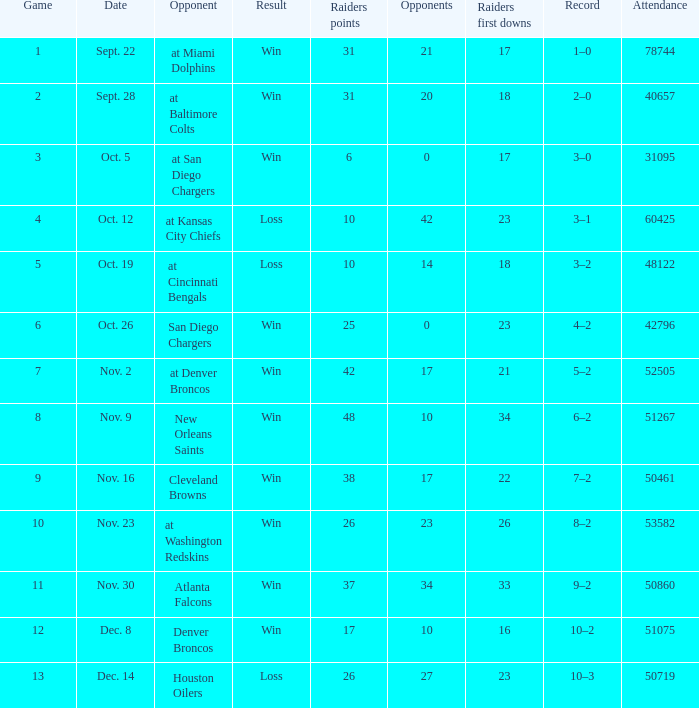Who was the game attended by 60425 people played against? At kansas city chiefs. 